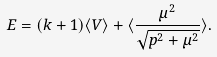<formula> <loc_0><loc_0><loc_500><loc_500>E = ( k + 1 ) \langle V \rangle + \langle { \frac { { \mu } ^ { 2 } } { \sqrt { { p } ^ { 2 } + { \mu } ^ { 2 } } } } \rangle .</formula> 